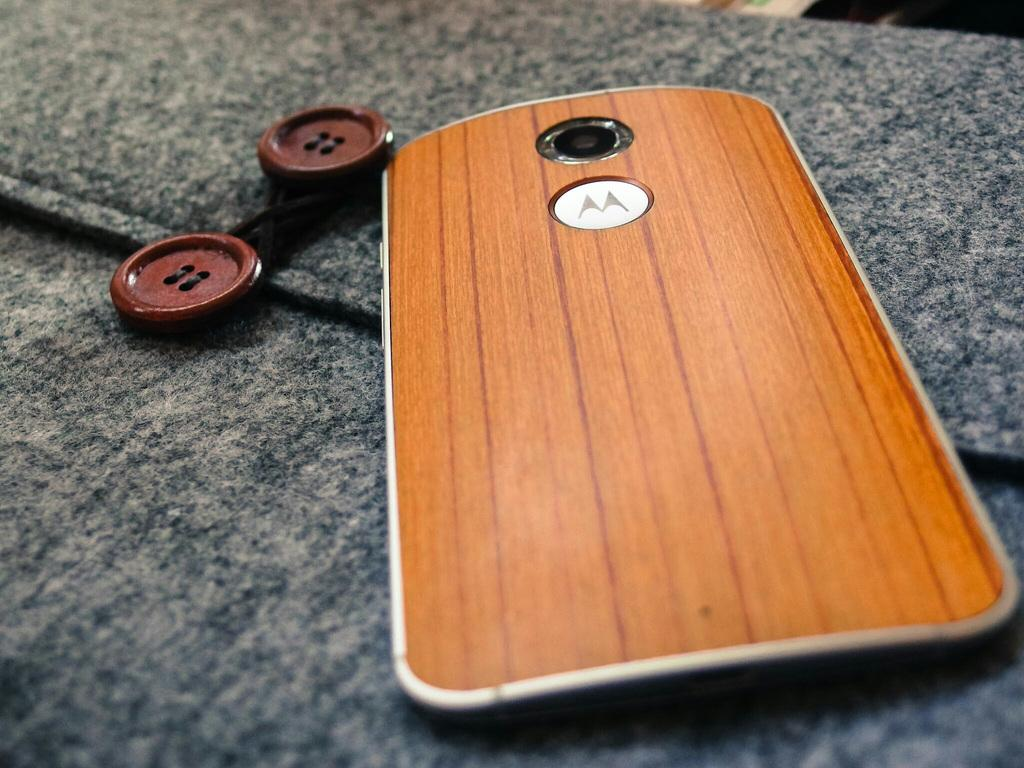<image>
Provide a brief description of the given image. a phone with the motorola 'm' logo with a wood case 